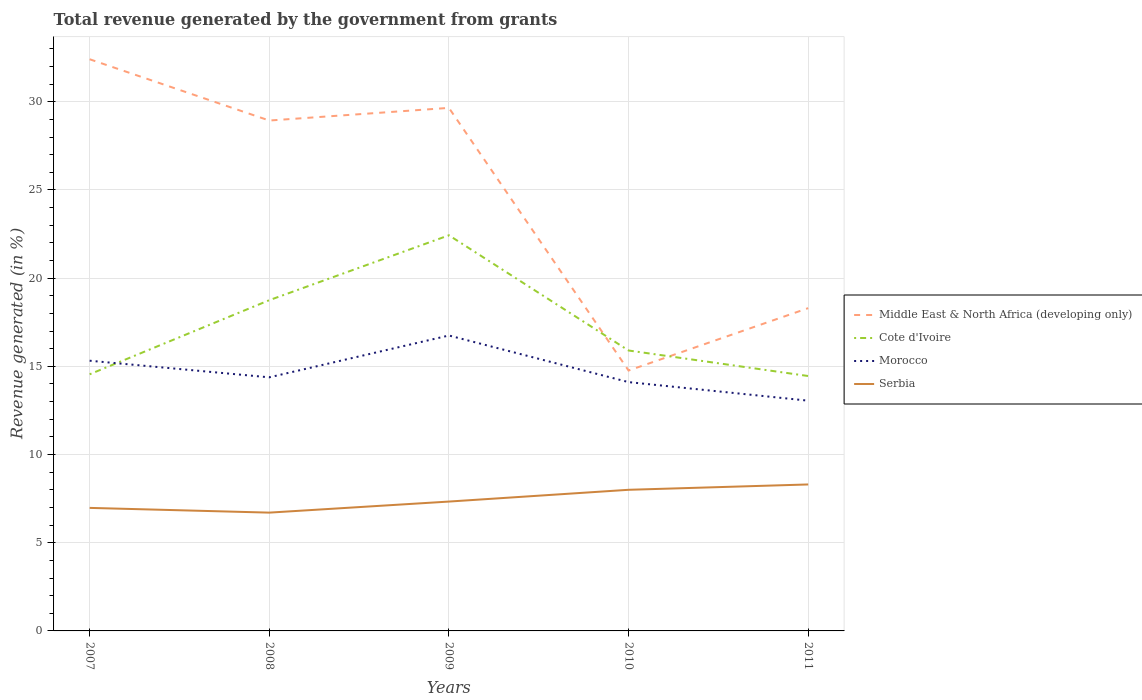How many different coloured lines are there?
Your response must be concise. 4. Across all years, what is the maximum total revenue generated in Middle East & North Africa (developing only)?
Provide a short and direct response. 14.76. What is the total total revenue generated in Morocco in the graph?
Your answer should be very brief. 2.64. What is the difference between the highest and the second highest total revenue generated in Middle East & North Africa (developing only)?
Give a very brief answer. 17.65. Is the total revenue generated in Cote d'Ivoire strictly greater than the total revenue generated in Middle East & North Africa (developing only) over the years?
Provide a succinct answer. No. How many lines are there?
Provide a short and direct response. 4. How many years are there in the graph?
Provide a succinct answer. 5. What is the difference between two consecutive major ticks on the Y-axis?
Provide a short and direct response. 5. Are the values on the major ticks of Y-axis written in scientific E-notation?
Ensure brevity in your answer.  No. What is the title of the graph?
Keep it short and to the point. Total revenue generated by the government from grants. What is the label or title of the X-axis?
Offer a very short reply. Years. What is the label or title of the Y-axis?
Offer a very short reply. Revenue generated (in %). What is the Revenue generated (in %) of Middle East & North Africa (developing only) in 2007?
Make the answer very short. 32.41. What is the Revenue generated (in %) in Cote d'Ivoire in 2007?
Give a very brief answer. 14.55. What is the Revenue generated (in %) of Morocco in 2007?
Provide a succinct answer. 15.32. What is the Revenue generated (in %) of Serbia in 2007?
Ensure brevity in your answer.  6.98. What is the Revenue generated (in %) in Middle East & North Africa (developing only) in 2008?
Keep it short and to the point. 28.94. What is the Revenue generated (in %) of Cote d'Ivoire in 2008?
Offer a very short reply. 18.75. What is the Revenue generated (in %) of Morocco in 2008?
Give a very brief answer. 14.38. What is the Revenue generated (in %) in Serbia in 2008?
Ensure brevity in your answer.  6.71. What is the Revenue generated (in %) of Middle East & North Africa (developing only) in 2009?
Make the answer very short. 29.65. What is the Revenue generated (in %) of Cote d'Ivoire in 2009?
Your answer should be compact. 22.43. What is the Revenue generated (in %) of Morocco in 2009?
Offer a terse response. 16.75. What is the Revenue generated (in %) in Serbia in 2009?
Your answer should be compact. 7.33. What is the Revenue generated (in %) in Middle East & North Africa (developing only) in 2010?
Offer a terse response. 14.76. What is the Revenue generated (in %) of Cote d'Ivoire in 2010?
Make the answer very short. 15.9. What is the Revenue generated (in %) in Morocco in 2010?
Your answer should be compact. 14.11. What is the Revenue generated (in %) in Serbia in 2010?
Your answer should be compact. 8. What is the Revenue generated (in %) of Middle East & North Africa (developing only) in 2011?
Ensure brevity in your answer.  18.3. What is the Revenue generated (in %) of Cote d'Ivoire in 2011?
Give a very brief answer. 14.45. What is the Revenue generated (in %) of Morocco in 2011?
Offer a terse response. 13.05. What is the Revenue generated (in %) of Serbia in 2011?
Offer a terse response. 8.3. Across all years, what is the maximum Revenue generated (in %) in Middle East & North Africa (developing only)?
Ensure brevity in your answer.  32.41. Across all years, what is the maximum Revenue generated (in %) in Cote d'Ivoire?
Give a very brief answer. 22.43. Across all years, what is the maximum Revenue generated (in %) in Morocco?
Offer a terse response. 16.75. Across all years, what is the maximum Revenue generated (in %) of Serbia?
Ensure brevity in your answer.  8.3. Across all years, what is the minimum Revenue generated (in %) in Middle East & North Africa (developing only)?
Your response must be concise. 14.76. Across all years, what is the minimum Revenue generated (in %) of Cote d'Ivoire?
Your response must be concise. 14.45. Across all years, what is the minimum Revenue generated (in %) of Morocco?
Give a very brief answer. 13.05. Across all years, what is the minimum Revenue generated (in %) in Serbia?
Keep it short and to the point. 6.71. What is the total Revenue generated (in %) of Middle East & North Africa (developing only) in the graph?
Provide a short and direct response. 124.07. What is the total Revenue generated (in %) in Cote d'Ivoire in the graph?
Provide a succinct answer. 86.08. What is the total Revenue generated (in %) in Morocco in the graph?
Provide a short and direct response. 73.61. What is the total Revenue generated (in %) in Serbia in the graph?
Your answer should be very brief. 37.32. What is the difference between the Revenue generated (in %) of Middle East & North Africa (developing only) in 2007 and that in 2008?
Provide a succinct answer. 3.47. What is the difference between the Revenue generated (in %) of Cote d'Ivoire in 2007 and that in 2008?
Provide a succinct answer. -4.2. What is the difference between the Revenue generated (in %) of Morocco in 2007 and that in 2008?
Offer a terse response. 0.94. What is the difference between the Revenue generated (in %) in Serbia in 2007 and that in 2008?
Give a very brief answer. 0.27. What is the difference between the Revenue generated (in %) in Middle East & North Africa (developing only) in 2007 and that in 2009?
Provide a succinct answer. 2.76. What is the difference between the Revenue generated (in %) of Cote d'Ivoire in 2007 and that in 2009?
Your answer should be very brief. -7.88. What is the difference between the Revenue generated (in %) of Morocco in 2007 and that in 2009?
Offer a terse response. -1.43. What is the difference between the Revenue generated (in %) in Serbia in 2007 and that in 2009?
Keep it short and to the point. -0.36. What is the difference between the Revenue generated (in %) in Middle East & North Africa (developing only) in 2007 and that in 2010?
Your answer should be very brief. 17.65. What is the difference between the Revenue generated (in %) of Cote d'Ivoire in 2007 and that in 2010?
Your answer should be very brief. -1.35. What is the difference between the Revenue generated (in %) of Morocco in 2007 and that in 2010?
Give a very brief answer. 1.21. What is the difference between the Revenue generated (in %) in Serbia in 2007 and that in 2010?
Offer a very short reply. -1.03. What is the difference between the Revenue generated (in %) in Middle East & North Africa (developing only) in 2007 and that in 2011?
Ensure brevity in your answer.  14.11. What is the difference between the Revenue generated (in %) in Cote d'Ivoire in 2007 and that in 2011?
Make the answer very short. 0.1. What is the difference between the Revenue generated (in %) of Morocco in 2007 and that in 2011?
Make the answer very short. 2.27. What is the difference between the Revenue generated (in %) of Serbia in 2007 and that in 2011?
Your response must be concise. -1.33. What is the difference between the Revenue generated (in %) in Middle East & North Africa (developing only) in 2008 and that in 2009?
Offer a terse response. -0.72. What is the difference between the Revenue generated (in %) in Cote d'Ivoire in 2008 and that in 2009?
Offer a terse response. -3.68. What is the difference between the Revenue generated (in %) of Morocco in 2008 and that in 2009?
Give a very brief answer. -2.37. What is the difference between the Revenue generated (in %) in Serbia in 2008 and that in 2009?
Offer a very short reply. -0.63. What is the difference between the Revenue generated (in %) of Middle East & North Africa (developing only) in 2008 and that in 2010?
Give a very brief answer. 14.17. What is the difference between the Revenue generated (in %) of Cote d'Ivoire in 2008 and that in 2010?
Provide a short and direct response. 2.85. What is the difference between the Revenue generated (in %) in Morocco in 2008 and that in 2010?
Your answer should be compact. 0.27. What is the difference between the Revenue generated (in %) of Serbia in 2008 and that in 2010?
Make the answer very short. -1.29. What is the difference between the Revenue generated (in %) in Middle East & North Africa (developing only) in 2008 and that in 2011?
Your answer should be very brief. 10.64. What is the difference between the Revenue generated (in %) of Cote d'Ivoire in 2008 and that in 2011?
Make the answer very short. 4.3. What is the difference between the Revenue generated (in %) in Morocco in 2008 and that in 2011?
Provide a succinct answer. 1.32. What is the difference between the Revenue generated (in %) of Serbia in 2008 and that in 2011?
Your response must be concise. -1.6. What is the difference between the Revenue generated (in %) of Middle East & North Africa (developing only) in 2009 and that in 2010?
Keep it short and to the point. 14.89. What is the difference between the Revenue generated (in %) of Cote d'Ivoire in 2009 and that in 2010?
Provide a succinct answer. 6.53. What is the difference between the Revenue generated (in %) in Morocco in 2009 and that in 2010?
Offer a very short reply. 2.64. What is the difference between the Revenue generated (in %) of Serbia in 2009 and that in 2010?
Your response must be concise. -0.67. What is the difference between the Revenue generated (in %) of Middle East & North Africa (developing only) in 2009 and that in 2011?
Give a very brief answer. 11.35. What is the difference between the Revenue generated (in %) of Cote d'Ivoire in 2009 and that in 2011?
Offer a terse response. 7.98. What is the difference between the Revenue generated (in %) in Morocco in 2009 and that in 2011?
Provide a succinct answer. 3.7. What is the difference between the Revenue generated (in %) in Serbia in 2009 and that in 2011?
Your answer should be very brief. -0.97. What is the difference between the Revenue generated (in %) in Middle East & North Africa (developing only) in 2010 and that in 2011?
Your response must be concise. -3.54. What is the difference between the Revenue generated (in %) in Cote d'Ivoire in 2010 and that in 2011?
Your response must be concise. 1.45. What is the difference between the Revenue generated (in %) in Morocco in 2010 and that in 2011?
Offer a terse response. 1.05. What is the difference between the Revenue generated (in %) of Serbia in 2010 and that in 2011?
Keep it short and to the point. -0.3. What is the difference between the Revenue generated (in %) of Middle East & North Africa (developing only) in 2007 and the Revenue generated (in %) of Cote d'Ivoire in 2008?
Provide a short and direct response. 13.66. What is the difference between the Revenue generated (in %) in Middle East & North Africa (developing only) in 2007 and the Revenue generated (in %) in Morocco in 2008?
Your answer should be compact. 18.03. What is the difference between the Revenue generated (in %) in Middle East & North Africa (developing only) in 2007 and the Revenue generated (in %) in Serbia in 2008?
Your response must be concise. 25.71. What is the difference between the Revenue generated (in %) of Cote d'Ivoire in 2007 and the Revenue generated (in %) of Morocco in 2008?
Ensure brevity in your answer.  0.17. What is the difference between the Revenue generated (in %) in Cote d'Ivoire in 2007 and the Revenue generated (in %) in Serbia in 2008?
Offer a very short reply. 7.84. What is the difference between the Revenue generated (in %) of Morocco in 2007 and the Revenue generated (in %) of Serbia in 2008?
Give a very brief answer. 8.61. What is the difference between the Revenue generated (in %) in Middle East & North Africa (developing only) in 2007 and the Revenue generated (in %) in Cote d'Ivoire in 2009?
Provide a short and direct response. 9.98. What is the difference between the Revenue generated (in %) of Middle East & North Africa (developing only) in 2007 and the Revenue generated (in %) of Morocco in 2009?
Make the answer very short. 15.66. What is the difference between the Revenue generated (in %) of Middle East & North Africa (developing only) in 2007 and the Revenue generated (in %) of Serbia in 2009?
Provide a succinct answer. 25.08. What is the difference between the Revenue generated (in %) of Cote d'Ivoire in 2007 and the Revenue generated (in %) of Morocco in 2009?
Ensure brevity in your answer.  -2.2. What is the difference between the Revenue generated (in %) of Cote d'Ivoire in 2007 and the Revenue generated (in %) of Serbia in 2009?
Your answer should be compact. 7.22. What is the difference between the Revenue generated (in %) in Morocco in 2007 and the Revenue generated (in %) in Serbia in 2009?
Provide a short and direct response. 7.99. What is the difference between the Revenue generated (in %) in Middle East & North Africa (developing only) in 2007 and the Revenue generated (in %) in Cote d'Ivoire in 2010?
Offer a very short reply. 16.51. What is the difference between the Revenue generated (in %) in Middle East & North Africa (developing only) in 2007 and the Revenue generated (in %) in Morocco in 2010?
Provide a succinct answer. 18.31. What is the difference between the Revenue generated (in %) of Middle East & North Africa (developing only) in 2007 and the Revenue generated (in %) of Serbia in 2010?
Give a very brief answer. 24.41. What is the difference between the Revenue generated (in %) of Cote d'Ivoire in 2007 and the Revenue generated (in %) of Morocco in 2010?
Ensure brevity in your answer.  0.44. What is the difference between the Revenue generated (in %) in Cote d'Ivoire in 2007 and the Revenue generated (in %) in Serbia in 2010?
Provide a succinct answer. 6.55. What is the difference between the Revenue generated (in %) in Morocco in 2007 and the Revenue generated (in %) in Serbia in 2010?
Provide a short and direct response. 7.32. What is the difference between the Revenue generated (in %) in Middle East & North Africa (developing only) in 2007 and the Revenue generated (in %) in Cote d'Ivoire in 2011?
Keep it short and to the point. 17.96. What is the difference between the Revenue generated (in %) in Middle East & North Africa (developing only) in 2007 and the Revenue generated (in %) in Morocco in 2011?
Give a very brief answer. 19.36. What is the difference between the Revenue generated (in %) of Middle East & North Africa (developing only) in 2007 and the Revenue generated (in %) of Serbia in 2011?
Your response must be concise. 24.11. What is the difference between the Revenue generated (in %) of Cote d'Ivoire in 2007 and the Revenue generated (in %) of Morocco in 2011?
Provide a short and direct response. 1.5. What is the difference between the Revenue generated (in %) of Cote d'Ivoire in 2007 and the Revenue generated (in %) of Serbia in 2011?
Your response must be concise. 6.25. What is the difference between the Revenue generated (in %) of Morocco in 2007 and the Revenue generated (in %) of Serbia in 2011?
Offer a very short reply. 7.02. What is the difference between the Revenue generated (in %) of Middle East & North Africa (developing only) in 2008 and the Revenue generated (in %) of Cote d'Ivoire in 2009?
Offer a terse response. 6.51. What is the difference between the Revenue generated (in %) in Middle East & North Africa (developing only) in 2008 and the Revenue generated (in %) in Morocco in 2009?
Provide a short and direct response. 12.19. What is the difference between the Revenue generated (in %) in Middle East & North Africa (developing only) in 2008 and the Revenue generated (in %) in Serbia in 2009?
Provide a succinct answer. 21.6. What is the difference between the Revenue generated (in %) in Cote d'Ivoire in 2008 and the Revenue generated (in %) in Morocco in 2009?
Your answer should be very brief. 2. What is the difference between the Revenue generated (in %) of Cote d'Ivoire in 2008 and the Revenue generated (in %) of Serbia in 2009?
Provide a short and direct response. 11.42. What is the difference between the Revenue generated (in %) of Morocco in 2008 and the Revenue generated (in %) of Serbia in 2009?
Keep it short and to the point. 7.04. What is the difference between the Revenue generated (in %) of Middle East & North Africa (developing only) in 2008 and the Revenue generated (in %) of Cote d'Ivoire in 2010?
Your answer should be very brief. 13.04. What is the difference between the Revenue generated (in %) of Middle East & North Africa (developing only) in 2008 and the Revenue generated (in %) of Morocco in 2010?
Make the answer very short. 14.83. What is the difference between the Revenue generated (in %) of Middle East & North Africa (developing only) in 2008 and the Revenue generated (in %) of Serbia in 2010?
Your answer should be compact. 20.94. What is the difference between the Revenue generated (in %) of Cote d'Ivoire in 2008 and the Revenue generated (in %) of Morocco in 2010?
Provide a succinct answer. 4.65. What is the difference between the Revenue generated (in %) of Cote d'Ivoire in 2008 and the Revenue generated (in %) of Serbia in 2010?
Keep it short and to the point. 10.75. What is the difference between the Revenue generated (in %) in Morocco in 2008 and the Revenue generated (in %) in Serbia in 2010?
Offer a terse response. 6.38. What is the difference between the Revenue generated (in %) of Middle East & North Africa (developing only) in 2008 and the Revenue generated (in %) of Cote d'Ivoire in 2011?
Your answer should be compact. 14.49. What is the difference between the Revenue generated (in %) of Middle East & North Africa (developing only) in 2008 and the Revenue generated (in %) of Morocco in 2011?
Make the answer very short. 15.88. What is the difference between the Revenue generated (in %) in Middle East & North Africa (developing only) in 2008 and the Revenue generated (in %) in Serbia in 2011?
Provide a succinct answer. 20.63. What is the difference between the Revenue generated (in %) in Cote d'Ivoire in 2008 and the Revenue generated (in %) in Morocco in 2011?
Ensure brevity in your answer.  5.7. What is the difference between the Revenue generated (in %) in Cote d'Ivoire in 2008 and the Revenue generated (in %) in Serbia in 2011?
Provide a succinct answer. 10.45. What is the difference between the Revenue generated (in %) in Morocco in 2008 and the Revenue generated (in %) in Serbia in 2011?
Your answer should be very brief. 6.07. What is the difference between the Revenue generated (in %) of Middle East & North Africa (developing only) in 2009 and the Revenue generated (in %) of Cote d'Ivoire in 2010?
Offer a very short reply. 13.76. What is the difference between the Revenue generated (in %) of Middle East & North Africa (developing only) in 2009 and the Revenue generated (in %) of Morocco in 2010?
Give a very brief answer. 15.55. What is the difference between the Revenue generated (in %) in Middle East & North Africa (developing only) in 2009 and the Revenue generated (in %) in Serbia in 2010?
Make the answer very short. 21.65. What is the difference between the Revenue generated (in %) in Cote d'Ivoire in 2009 and the Revenue generated (in %) in Morocco in 2010?
Keep it short and to the point. 8.32. What is the difference between the Revenue generated (in %) in Cote d'Ivoire in 2009 and the Revenue generated (in %) in Serbia in 2010?
Ensure brevity in your answer.  14.43. What is the difference between the Revenue generated (in %) in Morocco in 2009 and the Revenue generated (in %) in Serbia in 2010?
Give a very brief answer. 8.75. What is the difference between the Revenue generated (in %) of Middle East & North Africa (developing only) in 2009 and the Revenue generated (in %) of Cote d'Ivoire in 2011?
Give a very brief answer. 15.2. What is the difference between the Revenue generated (in %) in Middle East & North Africa (developing only) in 2009 and the Revenue generated (in %) in Morocco in 2011?
Keep it short and to the point. 16.6. What is the difference between the Revenue generated (in %) in Middle East & North Africa (developing only) in 2009 and the Revenue generated (in %) in Serbia in 2011?
Ensure brevity in your answer.  21.35. What is the difference between the Revenue generated (in %) in Cote d'Ivoire in 2009 and the Revenue generated (in %) in Morocco in 2011?
Your response must be concise. 9.38. What is the difference between the Revenue generated (in %) of Cote d'Ivoire in 2009 and the Revenue generated (in %) of Serbia in 2011?
Your response must be concise. 14.13. What is the difference between the Revenue generated (in %) of Morocco in 2009 and the Revenue generated (in %) of Serbia in 2011?
Make the answer very short. 8.45. What is the difference between the Revenue generated (in %) of Middle East & North Africa (developing only) in 2010 and the Revenue generated (in %) of Cote d'Ivoire in 2011?
Provide a short and direct response. 0.31. What is the difference between the Revenue generated (in %) in Middle East & North Africa (developing only) in 2010 and the Revenue generated (in %) in Morocco in 2011?
Your answer should be very brief. 1.71. What is the difference between the Revenue generated (in %) in Middle East & North Africa (developing only) in 2010 and the Revenue generated (in %) in Serbia in 2011?
Your answer should be compact. 6.46. What is the difference between the Revenue generated (in %) in Cote d'Ivoire in 2010 and the Revenue generated (in %) in Morocco in 2011?
Keep it short and to the point. 2.84. What is the difference between the Revenue generated (in %) in Cote d'Ivoire in 2010 and the Revenue generated (in %) in Serbia in 2011?
Make the answer very short. 7.59. What is the difference between the Revenue generated (in %) of Morocco in 2010 and the Revenue generated (in %) of Serbia in 2011?
Ensure brevity in your answer.  5.8. What is the average Revenue generated (in %) of Middle East & North Africa (developing only) per year?
Make the answer very short. 24.81. What is the average Revenue generated (in %) of Cote d'Ivoire per year?
Your answer should be compact. 17.22. What is the average Revenue generated (in %) of Morocco per year?
Make the answer very short. 14.72. What is the average Revenue generated (in %) of Serbia per year?
Make the answer very short. 7.46. In the year 2007, what is the difference between the Revenue generated (in %) in Middle East & North Africa (developing only) and Revenue generated (in %) in Cote d'Ivoire?
Offer a terse response. 17.86. In the year 2007, what is the difference between the Revenue generated (in %) of Middle East & North Africa (developing only) and Revenue generated (in %) of Morocco?
Offer a very short reply. 17.09. In the year 2007, what is the difference between the Revenue generated (in %) in Middle East & North Africa (developing only) and Revenue generated (in %) in Serbia?
Offer a terse response. 25.44. In the year 2007, what is the difference between the Revenue generated (in %) of Cote d'Ivoire and Revenue generated (in %) of Morocco?
Give a very brief answer. -0.77. In the year 2007, what is the difference between the Revenue generated (in %) of Cote d'Ivoire and Revenue generated (in %) of Serbia?
Make the answer very short. 7.58. In the year 2007, what is the difference between the Revenue generated (in %) in Morocco and Revenue generated (in %) in Serbia?
Make the answer very short. 8.35. In the year 2008, what is the difference between the Revenue generated (in %) of Middle East & North Africa (developing only) and Revenue generated (in %) of Cote d'Ivoire?
Your response must be concise. 10.19. In the year 2008, what is the difference between the Revenue generated (in %) of Middle East & North Africa (developing only) and Revenue generated (in %) of Morocco?
Offer a terse response. 14.56. In the year 2008, what is the difference between the Revenue generated (in %) in Middle East & North Africa (developing only) and Revenue generated (in %) in Serbia?
Keep it short and to the point. 22.23. In the year 2008, what is the difference between the Revenue generated (in %) of Cote d'Ivoire and Revenue generated (in %) of Morocco?
Your answer should be compact. 4.37. In the year 2008, what is the difference between the Revenue generated (in %) of Cote d'Ivoire and Revenue generated (in %) of Serbia?
Ensure brevity in your answer.  12.04. In the year 2008, what is the difference between the Revenue generated (in %) of Morocco and Revenue generated (in %) of Serbia?
Provide a succinct answer. 7.67. In the year 2009, what is the difference between the Revenue generated (in %) in Middle East & North Africa (developing only) and Revenue generated (in %) in Cote d'Ivoire?
Offer a terse response. 7.22. In the year 2009, what is the difference between the Revenue generated (in %) in Middle East & North Africa (developing only) and Revenue generated (in %) in Morocco?
Give a very brief answer. 12.9. In the year 2009, what is the difference between the Revenue generated (in %) in Middle East & North Africa (developing only) and Revenue generated (in %) in Serbia?
Give a very brief answer. 22.32. In the year 2009, what is the difference between the Revenue generated (in %) of Cote d'Ivoire and Revenue generated (in %) of Morocco?
Give a very brief answer. 5.68. In the year 2009, what is the difference between the Revenue generated (in %) of Cote d'Ivoire and Revenue generated (in %) of Serbia?
Provide a succinct answer. 15.1. In the year 2009, what is the difference between the Revenue generated (in %) of Morocco and Revenue generated (in %) of Serbia?
Your answer should be very brief. 9.42. In the year 2010, what is the difference between the Revenue generated (in %) of Middle East & North Africa (developing only) and Revenue generated (in %) of Cote d'Ivoire?
Ensure brevity in your answer.  -1.14. In the year 2010, what is the difference between the Revenue generated (in %) of Middle East & North Africa (developing only) and Revenue generated (in %) of Morocco?
Your answer should be very brief. 0.66. In the year 2010, what is the difference between the Revenue generated (in %) of Middle East & North Africa (developing only) and Revenue generated (in %) of Serbia?
Your response must be concise. 6.76. In the year 2010, what is the difference between the Revenue generated (in %) of Cote d'Ivoire and Revenue generated (in %) of Morocco?
Offer a very short reply. 1.79. In the year 2010, what is the difference between the Revenue generated (in %) in Cote d'Ivoire and Revenue generated (in %) in Serbia?
Offer a terse response. 7.9. In the year 2010, what is the difference between the Revenue generated (in %) in Morocco and Revenue generated (in %) in Serbia?
Your answer should be very brief. 6.11. In the year 2011, what is the difference between the Revenue generated (in %) in Middle East & North Africa (developing only) and Revenue generated (in %) in Cote d'Ivoire?
Offer a terse response. 3.85. In the year 2011, what is the difference between the Revenue generated (in %) of Middle East & North Africa (developing only) and Revenue generated (in %) of Morocco?
Give a very brief answer. 5.25. In the year 2011, what is the difference between the Revenue generated (in %) of Middle East & North Africa (developing only) and Revenue generated (in %) of Serbia?
Keep it short and to the point. 10. In the year 2011, what is the difference between the Revenue generated (in %) of Cote d'Ivoire and Revenue generated (in %) of Morocco?
Offer a very short reply. 1.4. In the year 2011, what is the difference between the Revenue generated (in %) in Cote d'Ivoire and Revenue generated (in %) in Serbia?
Your answer should be compact. 6.15. In the year 2011, what is the difference between the Revenue generated (in %) in Morocco and Revenue generated (in %) in Serbia?
Your answer should be compact. 4.75. What is the ratio of the Revenue generated (in %) in Middle East & North Africa (developing only) in 2007 to that in 2008?
Make the answer very short. 1.12. What is the ratio of the Revenue generated (in %) of Cote d'Ivoire in 2007 to that in 2008?
Provide a succinct answer. 0.78. What is the ratio of the Revenue generated (in %) in Morocco in 2007 to that in 2008?
Provide a succinct answer. 1.07. What is the ratio of the Revenue generated (in %) in Middle East & North Africa (developing only) in 2007 to that in 2009?
Offer a terse response. 1.09. What is the ratio of the Revenue generated (in %) of Cote d'Ivoire in 2007 to that in 2009?
Offer a terse response. 0.65. What is the ratio of the Revenue generated (in %) in Morocco in 2007 to that in 2009?
Keep it short and to the point. 0.91. What is the ratio of the Revenue generated (in %) of Serbia in 2007 to that in 2009?
Offer a terse response. 0.95. What is the ratio of the Revenue generated (in %) of Middle East & North Africa (developing only) in 2007 to that in 2010?
Provide a succinct answer. 2.2. What is the ratio of the Revenue generated (in %) of Cote d'Ivoire in 2007 to that in 2010?
Your answer should be compact. 0.92. What is the ratio of the Revenue generated (in %) in Morocco in 2007 to that in 2010?
Offer a terse response. 1.09. What is the ratio of the Revenue generated (in %) in Serbia in 2007 to that in 2010?
Give a very brief answer. 0.87. What is the ratio of the Revenue generated (in %) of Middle East & North Africa (developing only) in 2007 to that in 2011?
Ensure brevity in your answer.  1.77. What is the ratio of the Revenue generated (in %) in Cote d'Ivoire in 2007 to that in 2011?
Provide a short and direct response. 1.01. What is the ratio of the Revenue generated (in %) in Morocco in 2007 to that in 2011?
Offer a terse response. 1.17. What is the ratio of the Revenue generated (in %) in Serbia in 2007 to that in 2011?
Your response must be concise. 0.84. What is the ratio of the Revenue generated (in %) of Middle East & North Africa (developing only) in 2008 to that in 2009?
Your answer should be very brief. 0.98. What is the ratio of the Revenue generated (in %) of Cote d'Ivoire in 2008 to that in 2009?
Make the answer very short. 0.84. What is the ratio of the Revenue generated (in %) of Morocco in 2008 to that in 2009?
Your answer should be compact. 0.86. What is the ratio of the Revenue generated (in %) of Serbia in 2008 to that in 2009?
Make the answer very short. 0.91. What is the ratio of the Revenue generated (in %) of Middle East & North Africa (developing only) in 2008 to that in 2010?
Your answer should be compact. 1.96. What is the ratio of the Revenue generated (in %) in Cote d'Ivoire in 2008 to that in 2010?
Offer a terse response. 1.18. What is the ratio of the Revenue generated (in %) in Morocco in 2008 to that in 2010?
Offer a very short reply. 1.02. What is the ratio of the Revenue generated (in %) of Serbia in 2008 to that in 2010?
Offer a terse response. 0.84. What is the ratio of the Revenue generated (in %) in Middle East & North Africa (developing only) in 2008 to that in 2011?
Your answer should be very brief. 1.58. What is the ratio of the Revenue generated (in %) of Cote d'Ivoire in 2008 to that in 2011?
Keep it short and to the point. 1.3. What is the ratio of the Revenue generated (in %) in Morocco in 2008 to that in 2011?
Offer a very short reply. 1.1. What is the ratio of the Revenue generated (in %) in Serbia in 2008 to that in 2011?
Ensure brevity in your answer.  0.81. What is the ratio of the Revenue generated (in %) in Middle East & North Africa (developing only) in 2009 to that in 2010?
Provide a succinct answer. 2.01. What is the ratio of the Revenue generated (in %) of Cote d'Ivoire in 2009 to that in 2010?
Keep it short and to the point. 1.41. What is the ratio of the Revenue generated (in %) in Morocco in 2009 to that in 2010?
Your answer should be compact. 1.19. What is the ratio of the Revenue generated (in %) in Serbia in 2009 to that in 2010?
Keep it short and to the point. 0.92. What is the ratio of the Revenue generated (in %) of Middle East & North Africa (developing only) in 2009 to that in 2011?
Your answer should be compact. 1.62. What is the ratio of the Revenue generated (in %) of Cote d'Ivoire in 2009 to that in 2011?
Give a very brief answer. 1.55. What is the ratio of the Revenue generated (in %) of Morocco in 2009 to that in 2011?
Offer a very short reply. 1.28. What is the ratio of the Revenue generated (in %) in Serbia in 2009 to that in 2011?
Offer a very short reply. 0.88. What is the ratio of the Revenue generated (in %) in Middle East & North Africa (developing only) in 2010 to that in 2011?
Your response must be concise. 0.81. What is the ratio of the Revenue generated (in %) of Cote d'Ivoire in 2010 to that in 2011?
Make the answer very short. 1.1. What is the ratio of the Revenue generated (in %) of Morocco in 2010 to that in 2011?
Give a very brief answer. 1.08. What is the ratio of the Revenue generated (in %) in Serbia in 2010 to that in 2011?
Offer a terse response. 0.96. What is the difference between the highest and the second highest Revenue generated (in %) in Middle East & North Africa (developing only)?
Provide a succinct answer. 2.76. What is the difference between the highest and the second highest Revenue generated (in %) in Cote d'Ivoire?
Give a very brief answer. 3.68. What is the difference between the highest and the second highest Revenue generated (in %) in Morocco?
Offer a terse response. 1.43. What is the difference between the highest and the second highest Revenue generated (in %) in Serbia?
Your answer should be very brief. 0.3. What is the difference between the highest and the lowest Revenue generated (in %) of Middle East & North Africa (developing only)?
Give a very brief answer. 17.65. What is the difference between the highest and the lowest Revenue generated (in %) in Cote d'Ivoire?
Offer a terse response. 7.98. What is the difference between the highest and the lowest Revenue generated (in %) of Morocco?
Your response must be concise. 3.7. What is the difference between the highest and the lowest Revenue generated (in %) of Serbia?
Ensure brevity in your answer.  1.6. 